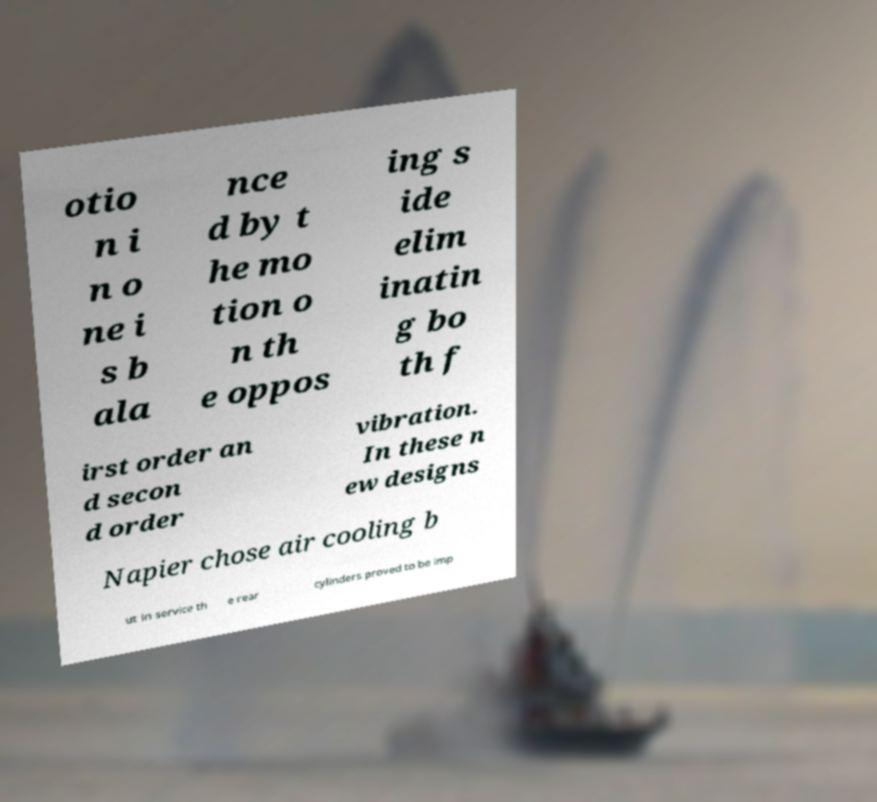Could you extract and type out the text from this image? otio n i n o ne i s b ala nce d by t he mo tion o n th e oppos ing s ide elim inatin g bo th f irst order an d secon d order vibration. In these n ew designs Napier chose air cooling b ut in service th e rear cylinders proved to be imp 